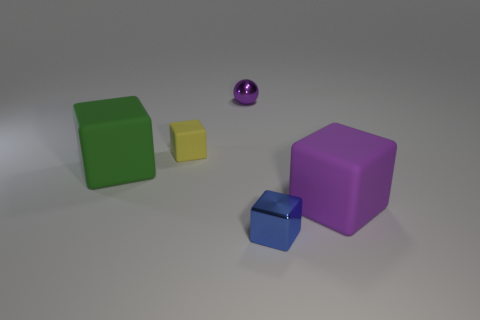What can you infer about the sizes of the blocks relative to each other? The blocks are of varying sizes, creating a visual hierarchy. The largest block appears to be a purple cube, which visually dominates the composition. The smaller blue and yellow blocks appear to be cube-shaped as well and are scaled down in a way that could indicate a proportional relationship or simply provide a contrast in size. Would you say the composition is more aesthetically pleasing due to the size variation? The variation in sizes creates a dynamic composition that is pleasing to the eye. It offers a balance between uniformity and diversity, adding visual interest and helping to guide the viewer's gaze across the scene. 